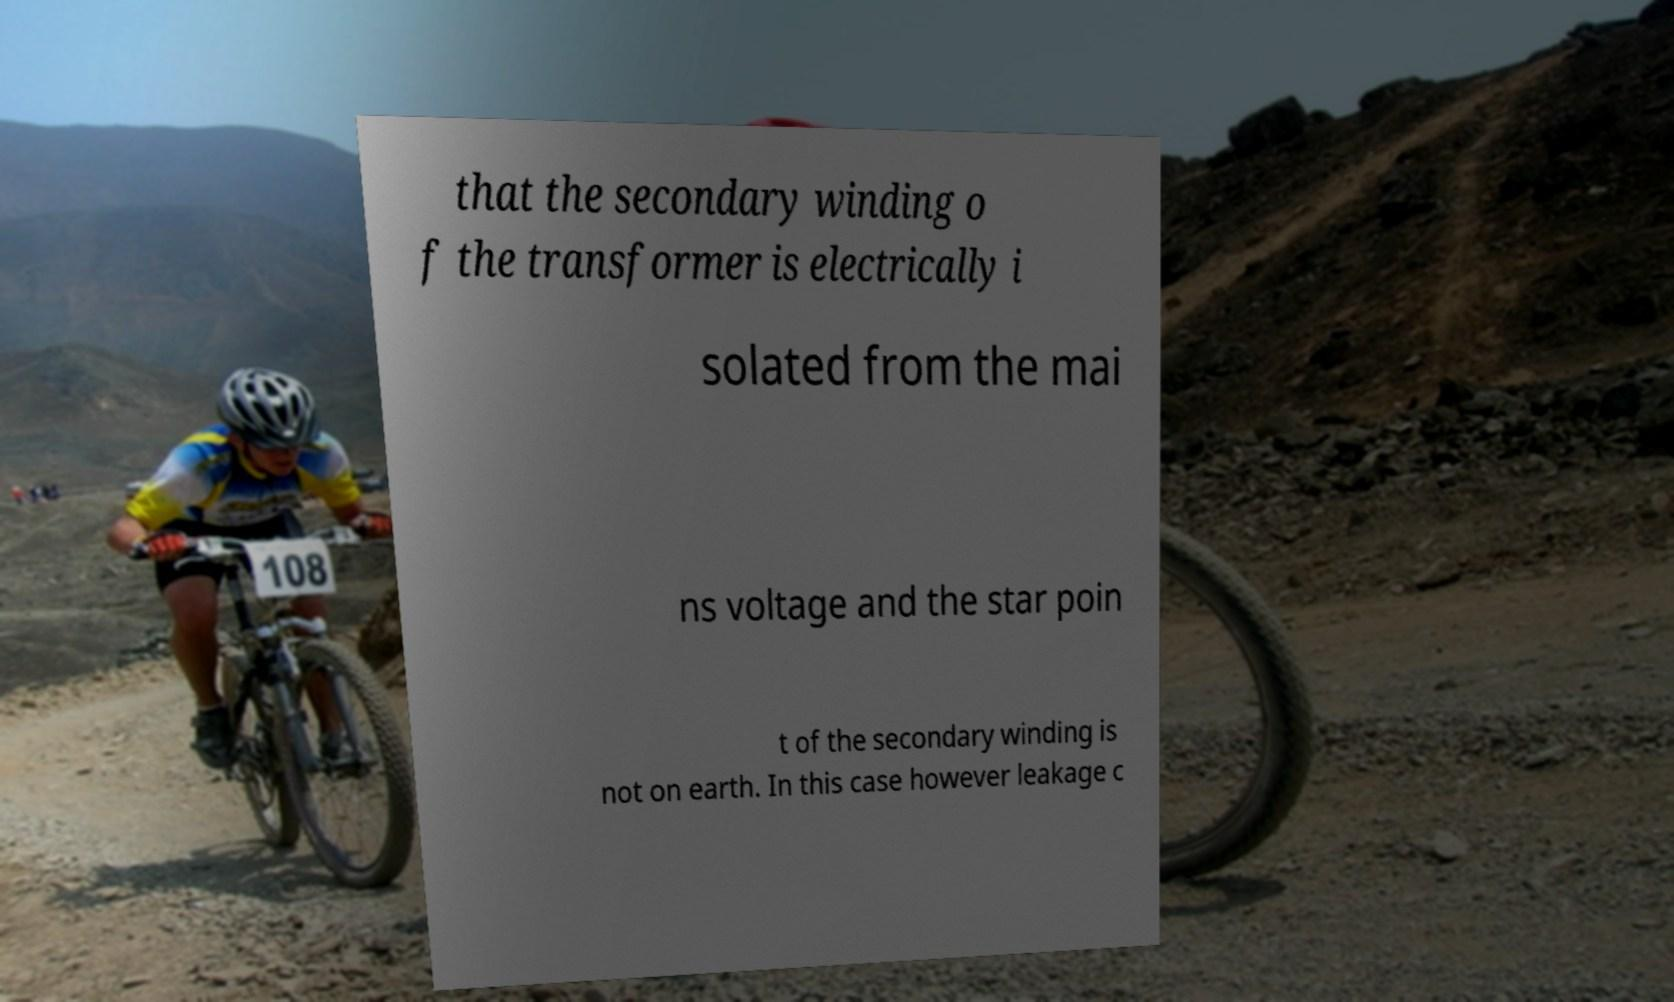Please identify and transcribe the text found in this image. that the secondary winding o f the transformer is electrically i solated from the mai ns voltage and the star poin t of the secondary winding is not on earth. In this case however leakage c 